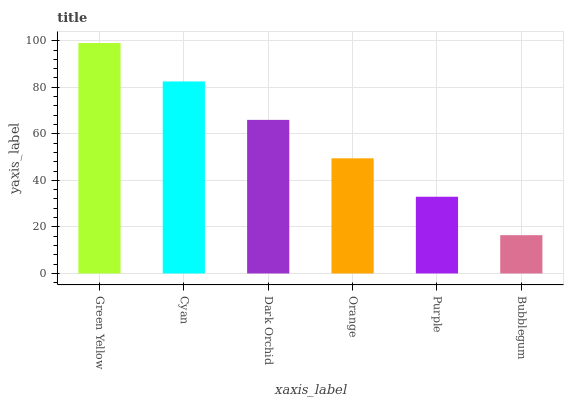Is Bubblegum the minimum?
Answer yes or no. Yes. Is Green Yellow the maximum?
Answer yes or no. Yes. Is Cyan the minimum?
Answer yes or no. No. Is Cyan the maximum?
Answer yes or no. No. Is Green Yellow greater than Cyan?
Answer yes or no. Yes. Is Cyan less than Green Yellow?
Answer yes or no. Yes. Is Cyan greater than Green Yellow?
Answer yes or no. No. Is Green Yellow less than Cyan?
Answer yes or no. No. Is Dark Orchid the high median?
Answer yes or no. Yes. Is Orange the low median?
Answer yes or no. Yes. Is Purple the high median?
Answer yes or no. No. Is Purple the low median?
Answer yes or no. No. 